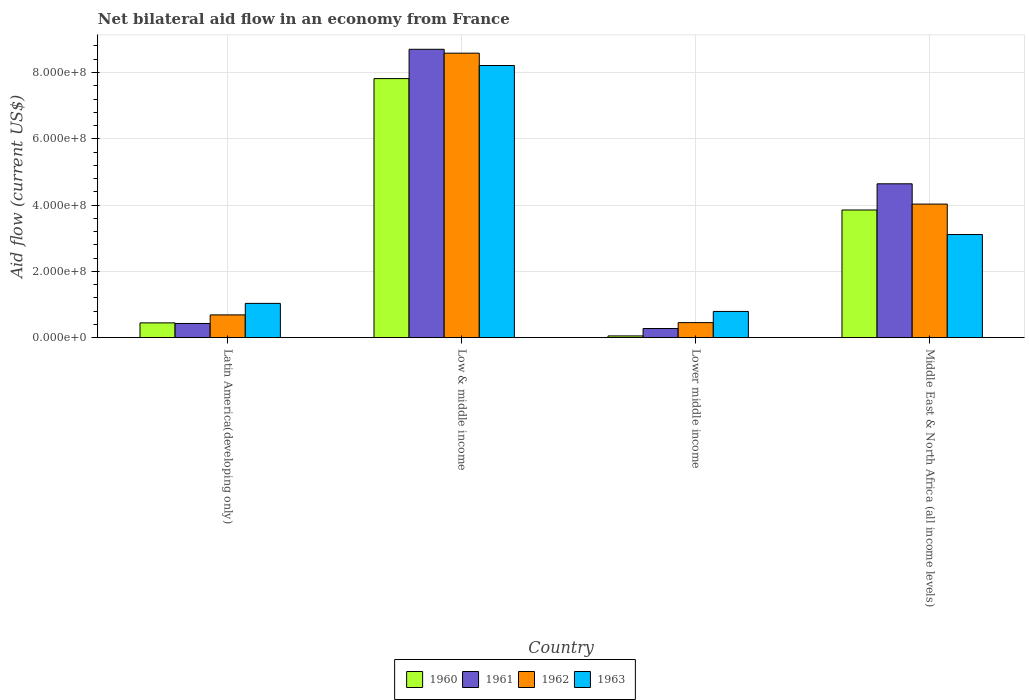Are the number of bars per tick equal to the number of legend labels?
Offer a very short reply. Yes. Are the number of bars on each tick of the X-axis equal?
Provide a succinct answer. Yes. How many bars are there on the 4th tick from the left?
Make the answer very short. 4. What is the label of the 1st group of bars from the left?
Provide a succinct answer. Latin America(developing only). In how many cases, is the number of bars for a given country not equal to the number of legend labels?
Ensure brevity in your answer.  0. What is the net bilateral aid flow in 1963 in Latin America(developing only)?
Give a very brief answer. 1.03e+08. Across all countries, what is the maximum net bilateral aid flow in 1960?
Your answer should be compact. 7.82e+08. Across all countries, what is the minimum net bilateral aid flow in 1963?
Ensure brevity in your answer.  7.91e+07. In which country was the net bilateral aid flow in 1962 maximum?
Ensure brevity in your answer.  Low & middle income. In which country was the net bilateral aid flow in 1963 minimum?
Provide a succinct answer. Lower middle income. What is the total net bilateral aid flow in 1963 in the graph?
Offer a terse response. 1.31e+09. What is the difference between the net bilateral aid flow in 1961 in Latin America(developing only) and that in Middle East & North Africa (all income levels)?
Your response must be concise. -4.21e+08. What is the difference between the net bilateral aid flow in 1960 in Low & middle income and the net bilateral aid flow in 1963 in Latin America(developing only)?
Make the answer very short. 6.78e+08. What is the average net bilateral aid flow in 1960 per country?
Your answer should be compact. 3.04e+08. What is the difference between the net bilateral aid flow of/in 1962 and net bilateral aid flow of/in 1961 in Latin America(developing only)?
Your answer should be very brief. 2.59e+07. In how many countries, is the net bilateral aid flow in 1961 greater than 640000000 US$?
Your answer should be compact. 1. What is the ratio of the net bilateral aid flow in 1962 in Latin America(developing only) to that in Lower middle income?
Your response must be concise. 1.51. What is the difference between the highest and the second highest net bilateral aid flow in 1962?
Offer a very short reply. 7.90e+08. What is the difference between the highest and the lowest net bilateral aid flow in 1961?
Make the answer very short. 8.42e+08. In how many countries, is the net bilateral aid flow in 1960 greater than the average net bilateral aid flow in 1960 taken over all countries?
Provide a short and direct response. 2. Is the sum of the net bilateral aid flow in 1962 in Latin America(developing only) and Lower middle income greater than the maximum net bilateral aid flow in 1961 across all countries?
Offer a terse response. No. Is it the case that in every country, the sum of the net bilateral aid flow in 1963 and net bilateral aid flow in 1960 is greater than the sum of net bilateral aid flow in 1961 and net bilateral aid flow in 1962?
Provide a short and direct response. No. What does the 4th bar from the left in Lower middle income represents?
Your answer should be very brief. 1963. Is it the case that in every country, the sum of the net bilateral aid flow in 1962 and net bilateral aid flow in 1960 is greater than the net bilateral aid flow in 1963?
Provide a short and direct response. No. How many bars are there?
Keep it short and to the point. 16. Are the values on the major ticks of Y-axis written in scientific E-notation?
Your response must be concise. Yes. Does the graph contain grids?
Give a very brief answer. Yes. Where does the legend appear in the graph?
Your response must be concise. Bottom center. How are the legend labels stacked?
Provide a short and direct response. Horizontal. What is the title of the graph?
Provide a short and direct response. Net bilateral aid flow in an economy from France. Does "1969" appear as one of the legend labels in the graph?
Give a very brief answer. No. What is the label or title of the X-axis?
Ensure brevity in your answer.  Country. What is the label or title of the Y-axis?
Your answer should be compact. Aid flow (current US$). What is the Aid flow (current US$) in 1960 in Latin America(developing only)?
Offer a terse response. 4.46e+07. What is the Aid flow (current US$) in 1961 in Latin America(developing only)?
Your answer should be very brief. 4.28e+07. What is the Aid flow (current US$) of 1962 in Latin America(developing only)?
Your answer should be compact. 6.87e+07. What is the Aid flow (current US$) of 1963 in Latin America(developing only)?
Ensure brevity in your answer.  1.03e+08. What is the Aid flow (current US$) of 1960 in Low & middle income?
Offer a terse response. 7.82e+08. What is the Aid flow (current US$) of 1961 in Low & middle income?
Offer a terse response. 8.70e+08. What is the Aid flow (current US$) in 1962 in Low & middle income?
Offer a very short reply. 8.58e+08. What is the Aid flow (current US$) in 1963 in Low & middle income?
Offer a very short reply. 8.21e+08. What is the Aid flow (current US$) in 1960 in Lower middle income?
Your answer should be very brief. 5.30e+06. What is the Aid flow (current US$) of 1961 in Lower middle income?
Your response must be concise. 2.76e+07. What is the Aid flow (current US$) of 1962 in Lower middle income?
Give a very brief answer. 4.54e+07. What is the Aid flow (current US$) in 1963 in Lower middle income?
Your answer should be compact. 7.91e+07. What is the Aid flow (current US$) in 1960 in Middle East & North Africa (all income levels)?
Make the answer very short. 3.85e+08. What is the Aid flow (current US$) in 1961 in Middle East & North Africa (all income levels)?
Offer a terse response. 4.64e+08. What is the Aid flow (current US$) of 1962 in Middle East & North Africa (all income levels)?
Make the answer very short. 4.03e+08. What is the Aid flow (current US$) in 1963 in Middle East & North Africa (all income levels)?
Your response must be concise. 3.11e+08. Across all countries, what is the maximum Aid flow (current US$) in 1960?
Give a very brief answer. 7.82e+08. Across all countries, what is the maximum Aid flow (current US$) in 1961?
Offer a very short reply. 8.70e+08. Across all countries, what is the maximum Aid flow (current US$) of 1962?
Your answer should be very brief. 8.58e+08. Across all countries, what is the maximum Aid flow (current US$) in 1963?
Your answer should be compact. 8.21e+08. Across all countries, what is the minimum Aid flow (current US$) in 1960?
Your response must be concise. 5.30e+06. Across all countries, what is the minimum Aid flow (current US$) in 1961?
Give a very brief answer. 2.76e+07. Across all countries, what is the minimum Aid flow (current US$) in 1962?
Your answer should be very brief. 4.54e+07. Across all countries, what is the minimum Aid flow (current US$) of 1963?
Offer a terse response. 7.91e+07. What is the total Aid flow (current US$) in 1960 in the graph?
Your response must be concise. 1.22e+09. What is the total Aid flow (current US$) in 1961 in the graph?
Offer a terse response. 1.40e+09. What is the total Aid flow (current US$) in 1962 in the graph?
Offer a terse response. 1.38e+09. What is the total Aid flow (current US$) in 1963 in the graph?
Provide a succinct answer. 1.31e+09. What is the difference between the Aid flow (current US$) of 1960 in Latin America(developing only) and that in Low & middle income?
Make the answer very short. -7.37e+08. What is the difference between the Aid flow (current US$) in 1961 in Latin America(developing only) and that in Low & middle income?
Your answer should be very brief. -8.27e+08. What is the difference between the Aid flow (current US$) in 1962 in Latin America(developing only) and that in Low & middle income?
Your answer should be very brief. -7.90e+08. What is the difference between the Aid flow (current US$) of 1963 in Latin America(developing only) and that in Low & middle income?
Offer a terse response. -7.18e+08. What is the difference between the Aid flow (current US$) of 1960 in Latin America(developing only) and that in Lower middle income?
Keep it short and to the point. 3.93e+07. What is the difference between the Aid flow (current US$) in 1961 in Latin America(developing only) and that in Lower middle income?
Ensure brevity in your answer.  1.52e+07. What is the difference between the Aid flow (current US$) in 1962 in Latin America(developing only) and that in Lower middle income?
Keep it short and to the point. 2.33e+07. What is the difference between the Aid flow (current US$) in 1963 in Latin America(developing only) and that in Lower middle income?
Give a very brief answer. 2.43e+07. What is the difference between the Aid flow (current US$) of 1960 in Latin America(developing only) and that in Middle East & North Africa (all income levels)?
Provide a succinct answer. -3.41e+08. What is the difference between the Aid flow (current US$) in 1961 in Latin America(developing only) and that in Middle East & North Africa (all income levels)?
Ensure brevity in your answer.  -4.21e+08. What is the difference between the Aid flow (current US$) of 1962 in Latin America(developing only) and that in Middle East & North Africa (all income levels)?
Offer a terse response. -3.34e+08. What is the difference between the Aid flow (current US$) in 1963 in Latin America(developing only) and that in Middle East & North Africa (all income levels)?
Your answer should be compact. -2.08e+08. What is the difference between the Aid flow (current US$) of 1960 in Low & middle income and that in Lower middle income?
Give a very brief answer. 7.76e+08. What is the difference between the Aid flow (current US$) of 1961 in Low & middle income and that in Lower middle income?
Make the answer very short. 8.42e+08. What is the difference between the Aid flow (current US$) of 1962 in Low & middle income and that in Lower middle income?
Ensure brevity in your answer.  8.13e+08. What is the difference between the Aid flow (current US$) of 1963 in Low & middle income and that in Lower middle income?
Your answer should be very brief. 7.42e+08. What is the difference between the Aid flow (current US$) of 1960 in Low & middle income and that in Middle East & North Africa (all income levels)?
Your answer should be compact. 3.96e+08. What is the difference between the Aid flow (current US$) of 1961 in Low & middle income and that in Middle East & North Africa (all income levels)?
Your answer should be very brief. 4.06e+08. What is the difference between the Aid flow (current US$) of 1962 in Low & middle income and that in Middle East & North Africa (all income levels)?
Your answer should be very brief. 4.55e+08. What is the difference between the Aid flow (current US$) in 1963 in Low & middle income and that in Middle East & North Africa (all income levels)?
Keep it short and to the point. 5.10e+08. What is the difference between the Aid flow (current US$) of 1960 in Lower middle income and that in Middle East & North Africa (all income levels)?
Provide a succinct answer. -3.80e+08. What is the difference between the Aid flow (current US$) in 1961 in Lower middle income and that in Middle East & North Africa (all income levels)?
Provide a succinct answer. -4.37e+08. What is the difference between the Aid flow (current US$) in 1962 in Lower middle income and that in Middle East & North Africa (all income levels)?
Ensure brevity in your answer.  -3.58e+08. What is the difference between the Aid flow (current US$) of 1963 in Lower middle income and that in Middle East & North Africa (all income levels)?
Keep it short and to the point. -2.32e+08. What is the difference between the Aid flow (current US$) of 1960 in Latin America(developing only) and the Aid flow (current US$) of 1961 in Low & middle income?
Make the answer very short. -8.25e+08. What is the difference between the Aid flow (current US$) of 1960 in Latin America(developing only) and the Aid flow (current US$) of 1962 in Low & middle income?
Provide a succinct answer. -8.14e+08. What is the difference between the Aid flow (current US$) of 1960 in Latin America(developing only) and the Aid flow (current US$) of 1963 in Low & middle income?
Your answer should be very brief. -7.76e+08. What is the difference between the Aid flow (current US$) in 1961 in Latin America(developing only) and the Aid flow (current US$) in 1962 in Low & middle income?
Provide a succinct answer. -8.16e+08. What is the difference between the Aid flow (current US$) in 1961 in Latin America(developing only) and the Aid flow (current US$) in 1963 in Low & middle income?
Your answer should be compact. -7.78e+08. What is the difference between the Aid flow (current US$) in 1962 in Latin America(developing only) and the Aid flow (current US$) in 1963 in Low & middle income?
Give a very brief answer. -7.52e+08. What is the difference between the Aid flow (current US$) in 1960 in Latin America(developing only) and the Aid flow (current US$) in 1961 in Lower middle income?
Your answer should be compact. 1.70e+07. What is the difference between the Aid flow (current US$) of 1960 in Latin America(developing only) and the Aid flow (current US$) of 1962 in Lower middle income?
Give a very brief answer. -8.00e+05. What is the difference between the Aid flow (current US$) of 1960 in Latin America(developing only) and the Aid flow (current US$) of 1963 in Lower middle income?
Your answer should be compact. -3.45e+07. What is the difference between the Aid flow (current US$) in 1961 in Latin America(developing only) and the Aid flow (current US$) in 1962 in Lower middle income?
Make the answer very short. -2.60e+06. What is the difference between the Aid flow (current US$) in 1961 in Latin America(developing only) and the Aid flow (current US$) in 1963 in Lower middle income?
Your answer should be very brief. -3.63e+07. What is the difference between the Aid flow (current US$) in 1962 in Latin America(developing only) and the Aid flow (current US$) in 1963 in Lower middle income?
Your answer should be compact. -1.04e+07. What is the difference between the Aid flow (current US$) of 1960 in Latin America(developing only) and the Aid flow (current US$) of 1961 in Middle East & North Africa (all income levels)?
Keep it short and to the point. -4.20e+08. What is the difference between the Aid flow (current US$) of 1960 in Latin America(developing only) and the Aid flow (current US$) of 1962 in Middle East & North Africa (all income levels)?
Make the answer very short. -3.58e+08. What is the difference between the Aid flow (current US$) in 1960 in Latin America(developing only) and the Aid flow (current US$) in 1963 in Middle East & North Africa (all income levels)?
Make the answer very short. -2.66e+08. What is the difference between the Aid flow (current US$) of 1961 in Latin America(developing only) and the Aid flow (current US$) of 1962 in Middle East & North Africa (all income levels)?
Provide a succinct answer. -3.60e+08. What is the difference between the Aid flow (current US$) of 1961 in Latin America(developing only) and the Aid flow (current US$) of 1963 in Middle East & North Africa (all income levels)?
Offer a terse response. -2.68e+08. What is the difference between the Aid flow (current US$) of 1962 in Latin America(developing only) and the Aid flow (current US$) of 1963 in Middle East & North Africa (all income levels)?
Ensure brevity in your answer.  -2.42e+08. What is the difference between the Aid flow (current US$) in 1960 in Low & middle income and the Aid flow (current US$) in 1961 in Lower middle income?
Offer a very short reply. 7.54e+08. What is the difference between the Aid flow (current US$) in 1960 in Low & middle income and the Aid flow (current US$) in 1962 in Lower middle income?
Give a very brief answer. 7.36e+08. What is the difference between the Aid flow (current US$) in 1960 in Low & middle income and the Aid flow (current US$) in 1963 in Lower middle income?
Ensure brevity in your answer.  7.02e+08. What is the difference between the Aid flow (current US$) of 1961 in Low & middle income and the Aid flow (current US$) of 1962 in Lower middle income?
Ensure brevity in your answer.  8.25e+08. What is the difference between the Aid flow (current US$) of 1961 in Low & middle income and the Aid flow (current US$) of 1963 in Lower middle income?
Make the answer very short. 7.91e+08. What is the difference between the Aid flow (current US$) of 1962 in Low & middle income and the Aid flow (current US$) of 1963 in Lower middle income?
Provide a short and direct response. 7.79e+08. What is the difference between the Aid flow (current US$) of 1960 in Low & middle income and the Aid flow (current US$) of 1961 in Middle East & North Africa (all income levels)?
Provide a short and direct response. 3.17e+08. What is the difference between the Aid flow (current US$) in 1960 in Low & middle income and the Aid flow (current US$) in 1962 in Middle East & North Africa (all income levels)?
Provide a short and direct response. 3.79e+08. What is the difference between the Aid flow (current US$) in 1960 in Low & middle income and the Aid flow (current US$) in 1963 in Middle East & North Africa (all income levels)?
Your answer should be very brief. 4.70e+08. What is the difference between the Aid flow (current US$) of 1961 in Low & middle income and the Aid flow (current US$) of 1962 in Middle East & North Africa (all income levels)?
Give a very brief answer. 4.67e+08. What is the difference between the Aid flow (current US$) in 1961 in Low & middle income and the Aid flow (current US$) in 1963 in Middle East & North Africa (all income levels)?
Offer a terse response. 5.59e+08. What is the difference between the Aid flow (current US$) in 1962 in Low & middle income and the Aid flow (current US$) in 1963 in Middle East & North Africa (all income levels)?
Keep it short and to the point. 5.47e+08. What is the difference between the Aid flow (current US$) of 1960 in Lower middle income and the Aid flow (current US$) of 1961 in Middle East & North Africa (all income levels)?
Your answer should be very brief. -4.59e+08. What is the difference between the Aid flow (current US$) in 1960 in Lower middle income and the Aid flow (current US$) in 1962 in Middle East & North Africa (all income levels)?
Ensure brevity in your answer.  -3.98e+08. What is the difference between the Aid flow (current US$) of 1960 in Lower middle income and the Aid flow (current US$) of 1963 in Middle East & North Africa (all income levels)?
Your answer should be very brief. -3.06e+08. What is the difference between the Aid flow (current US$) in 1961 in Lower middle income and the Aid flow (current US$) in 1962 in Middle East & North Africa (all income levels)?
Make the answer very short. -3.75e+08. What is the difference between the Aid flow (current US$) of 1961 in Lower middle income and the Aid flow (current US$) of 1963 in Middle East & North Africa (all income levels)?
Your response must be concise. -2.84e+08. What is the difference between the Aid flow (current US$) in 1962 in Lower middle income and the Aid flow (current US$) in 1963 in Middle East & North Africa (all income levels)?
Your answer should be compact. -2.66e+08. What is the average Aid flow (current US$) in 1960 per country?
Ensure brevity in your answer.  3.04e+08. What is the average Aid flow (current US$) in 1961 per country?
Give a very brief answer. 3.51e+08. What is the average Aid flow (current US$) in 1962 per country?
Make the answer very short. 3.44e+08. What is the average Aid flow (current US$) of 1963 per country?
Your response must be concise. 3.29e+08. What is the difference between the Aid flow (current US$) of 1960 and Aid flow (current US$) of 1961 in Latin America(developing only)?
Your answer should be compact. 1.80e+06. What is the difference between the Aid flow (current US$) of 1960 and Aid flow (current US$) of 1962 in Latin America(developing only)?
Keep it short and to the point. -2.41e+07. What is the difference between the Aid flow (current US$) of 1960 and Aid flow (current US$) of 1963 in Latin America(developing only)?
Ensure brevity in your answer.  -5.88e+07. What is the difference between the Aid flow (current US$) in 1961 and Aid flow (current US$) in 1962 in Latin America(developing only)?
Make the answer very short. -2.59e+07. What is the difference between the Aid flow (current US$) in 1961 and Aid flow (current US$) in 1963 in Latin America(developing only)?
Keep it short and to the point. -6.06e+07. What is the difference between the Aid flow (current US$) in 1962 and Aid flow (current US$) in 1963 in Latin America(developing only)?
Make the answer very short. -3.47e+07. What is the difference between the Aid flow (current US$) in 1960 and Aid flow (current US$) in 1961 in Low & middle income?
Offer a very short reply. -8.84e+07. What is the difference between the Aid flow (current US$) in 1960 and Aid flow (current US$) in 1962 in Low & middle income?
Offer a very short reply. -7.67e+07. What is the difference between the Aid flow (current US$) in 1960 and Aid flow (current US$) in 1963 in Low & middle income?
Keep it short and to the point. -3.95e+07. What is the difference between the Aid flow (current US$) in 1961 and Aid flow (current US$) in 1962 in Low & middle income?
Offer a very short reply. 1.17e+07. What is the difference between the Aid flow (current US$) in 1961 and Aid flow (current US$) in 1963 in Low & middle income?
Provide a succinct answer. 4.89e+07. What is the difference between the Aid flow (current US$) of 1962 and Aid flow (current US$) of 1963 in Low & middle income?
Offer a terse response. 3.72e+07. What is the difference between the Aid flow (current US$) in 1960 and Aid flow (current US$) in 1961 in Lower middle income?
Provide a succinct answer. -2.23e+07. What is the difference between the Aid flow (current US$) in 1960 and Aid flow (current US$) in 1962 in Lower middle income?
Offer a very short reply. -4.01e+07. What is the difference between the Aid flow (current US$) in 1960 and Aid flow (current US$) in 1963 in Lower middle income?
Provide a short and direct response. -7.38e+07. What is the difference between the Aid flow (current US$) of 1961 and Aid flow (current US$) of 1962 in Lower middle income?
Make the answer very short. -1.78e+07. What is the difference between the Aid flow (current US$) in 1961 and Aid flow (current US$) in 1963 in Lower middle income?
Provide a succinct answer. -5.15e+07. What is the difference between the Aid flow (current US$) of 1962 and Aid flow (current US$) of 1963 in Lower middle income?
Your response must be concise. -3.37e+07. What is the difference between the Aid flow (current US$) of 1960 and Aid flow (current US$) of 1961 in Middle East & North Africa (all income levels)?
Ensure brevity in your answer.  -7.90e+07. What is the difference between the Aid flow (current US$) in 1960 and Aid flow (current US$) in 1962 in Middle East & North Africa (all income levels)?
Provide a succinct answer. -1.78e+07. What is the difference between the Aid flow (current US$) of 1960 and Aid flow (current US$) of 1963 in Middle East & North Africa (all income levels)?
Provide a succinct answer. 7.41e+07. What is the difference between the Aid flow (current US$) in 1961 and Aid flow (current US$) in 1962 in Middle East & North Africa (all income levels)?
Offer a terse response. 6.12e+07. What is the difference between the Aid flow (current US$) of 1961 and Aid flow (current US$) of 1963 in Middle East & North Africa (all income levels)?
Keep it short and to the point. 1.53e+08. What is the difference between the Aid flow (current US$) in 1962 and Aid flow (current US$) in 1963 in Middle East & North Africa (all income levels)?
Offer a terse response. 9.19e+07. What is the ratio of the Aid flow (current US$) of 1960 in Latin America(developing only) to that in Low & middle income?
Give a very brief answer. 0.06. What is the ratio of the Aid flow (current US$) of 1961 in Latin America(developing only) to that in Low & middle income?
Offer a terse response. 0.05. What is the ratio of the Aid flow (current US$) of 1962 in Latin America(developing only) to that in Low & middle income?
Provide a succinct answer. 0.08. What is the ratio of the Aid flow (current US$) in 1963 in Latin America(developing only) to that in Low & middle income?
Give a very brief answer. 0.13. What is the ratio of the Aid flow (current US$) in 1960 in Latin America(developing only) to that in Lower middle income?
Make the answer very short. 8.42. What is the ratio of the Aid flow (current US$) of 1961 in Latin America(developing only) to that in Lower middle income?
Ensure brevity in your answer.  1.55. What is the ratio of the Aid flow (current US$) in 1962 in Latin America(developing only) to that in Lower middle income?
Offer a very short reply. 1.51. What is the ratio of the Aid flow (current US$) in 1963 in Latin America(developing only) to that in Lower middle income?
Ensure brevity in your answer.  1.31. What is the ratio of the Aid flow (current US$) in 1960 in Latin America(developing only) to that in Middle East & North Africa (all income levels)?
Offer a very short reply. 0.12. What is the ratio of the Aid flow (current US$) in 1961 in Latin America(developing only) to that in Middle East & North Africa (all income levels)?
Give a very brief answer. 0.09. What is the ratio of the Aid flow (current US$) of 1962 in Latin America(developing only) to that in Middle East & North Africa (all income levels)?
Provide a short and direct response. 0.17. What is the ratio of the Aid flow (current US$) of 1963 in Latin America(developing only) to that in Middle East & North Africa (all income levels)?
Your response must be concise. 0.33. What is the ratio of the Aid flow (current US$) in 1960 in Low & middle income to that in Lower middle income?
Ensure brevity in your answer.  147.47. What is the ratio of the Aid flow (current US$) of 1961 in Low & middle income to that in Lower middle income?
Your response must be concise. 31.52. What is the ratio of the Aid flow (current US$) of 1962 in Low & middle income to that in Lower middle income?
Ensure brevity in your answer.  18.91. What is the ratio of the Aid flow (current US$) in 1963 in Low & middle income to that in Lower middle income?
Give a very brief answer. 10.38. What is the ratio of the Aid flow (current US$) in 1960 in Low & middle income to that in Middle East & North Africa (all income levels)?
Your answer should be very brief. 2.03. What is the ratio of the Aid flow (current US$) of 1961 in Low & middle income to that in Middle East & North Africa (all income levels)?
Provide a succinct answer. 1.87. What is the ratio of the Aid flow (current US$) of 1962 in Low & middle income to that in Middle East & North Africa (all income levels)?
Keep it short and to the point. 2.13. What is the ratio of the Aid flow (current US$) in 1963 in Low & middle income to that in Middle East & North Africa (all income levels)?
Give a very brief answer. 2.64. What is the ratio of the Aid flow (current US$) of 1960 in Lower middle income to that in Middle East & North Africa (all income levels)?
Offer a very short reply. 0.01. What is the ratio of the Aid flow (current US$) of 1961 in Lower middle income to that in Middle East & North Africa (all income levels)?
Your answer should be compact. 0.06. What is the ratio of the Aid flow (current US$) of 1962 in Lower middle income to that in Middle East & North Africa (all income levels)?
Ensure brevity in your answer.  0.11. What is the ratio of the Aid flow (current US$) of 1963 in Lower middle income to that in Middle East & North Africa (all income levels)?
Make the answer very short. 0.25. What is the difference between the highest and the second highest Aid flow (current US$) of 1960?
Your answer should be compact. 3.96e+08. What is the difference between the highest and the second highest Aid flow (current US$) of 1961?
Keep it short and to the point. 4.06e+08. What is the difference between the highest and the second highest Aid flow (current US$) of 1962?
Provide a succinct answer. 4.55e+08. What is the difference between the highest and the second highest Aid flow (current US$) of 1963?
Keep it short and to the point. 5.10e+08. What is the difference between the highest and the lowest Aid flow (current US$) in 1960?
Give a very brief answer. 7.76e+08. What is the difference between the highest and the lowest Aid flow (current US$) of 1961?
Keep it short and to the point. 8.42e+08. What is the difference between the highest and the lowest Aid flow (current US$) in 1962?
Your answer should be very brief. 8.13e+08. What is the difference between the highest and the lowest Aid flow (current US$) in 1963?
Provide a succinct answer. 7.42e+08. 